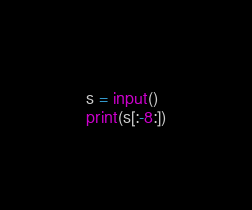Convert code to text. <code><loc_0><loc_0><loc_500><loc_500><_Python_>s = input()
print(s[:-8:])</code> 